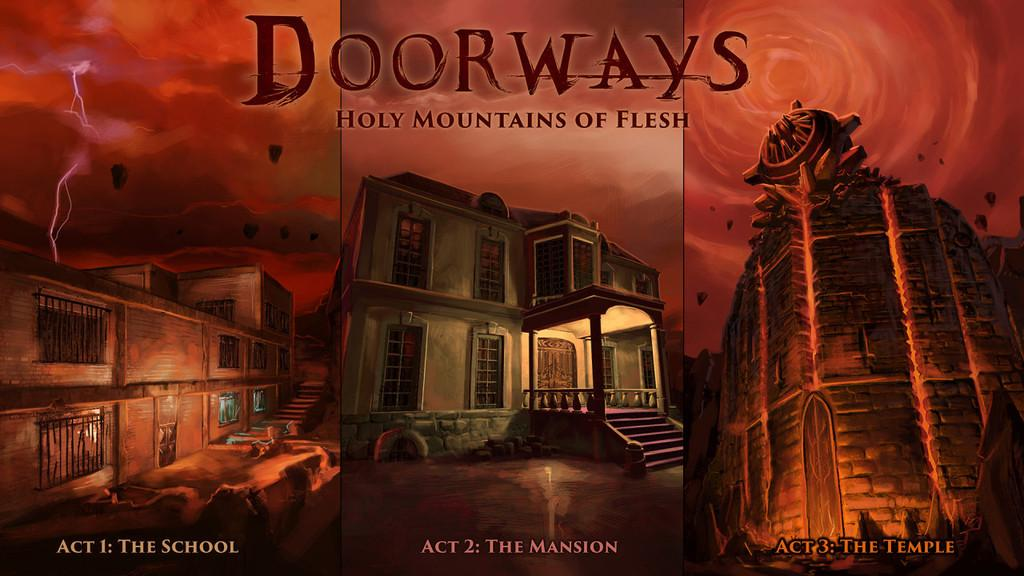Provide a one-sentence caption for the provided image. A Three Act series, Dorways, all laid out side by side. 